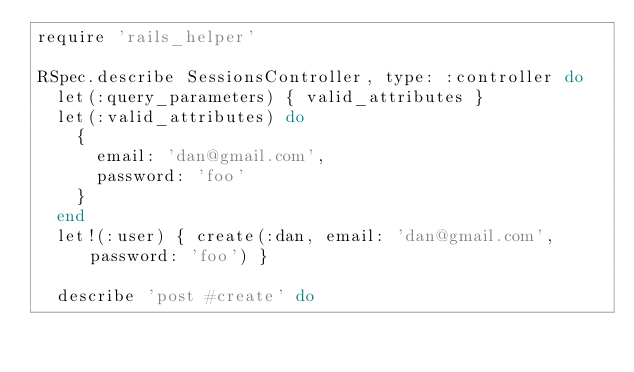<code> <loc_0><loc_0><loc_500><loc_500><_Ruby_>require 'rails_helper'

RSpec.describe SessionsController, type: :controller do
  let(:query_parameters) { valid_attributes }
  let(:valid_attributes) do
    {
      email: 'dan@gmail.com',
      password: 'foo'
    }
  end
  let!(:user) { create(:dan, email: 'dan@gmail.com', password: 'foo') }

  describe 'post #create' do</code> 